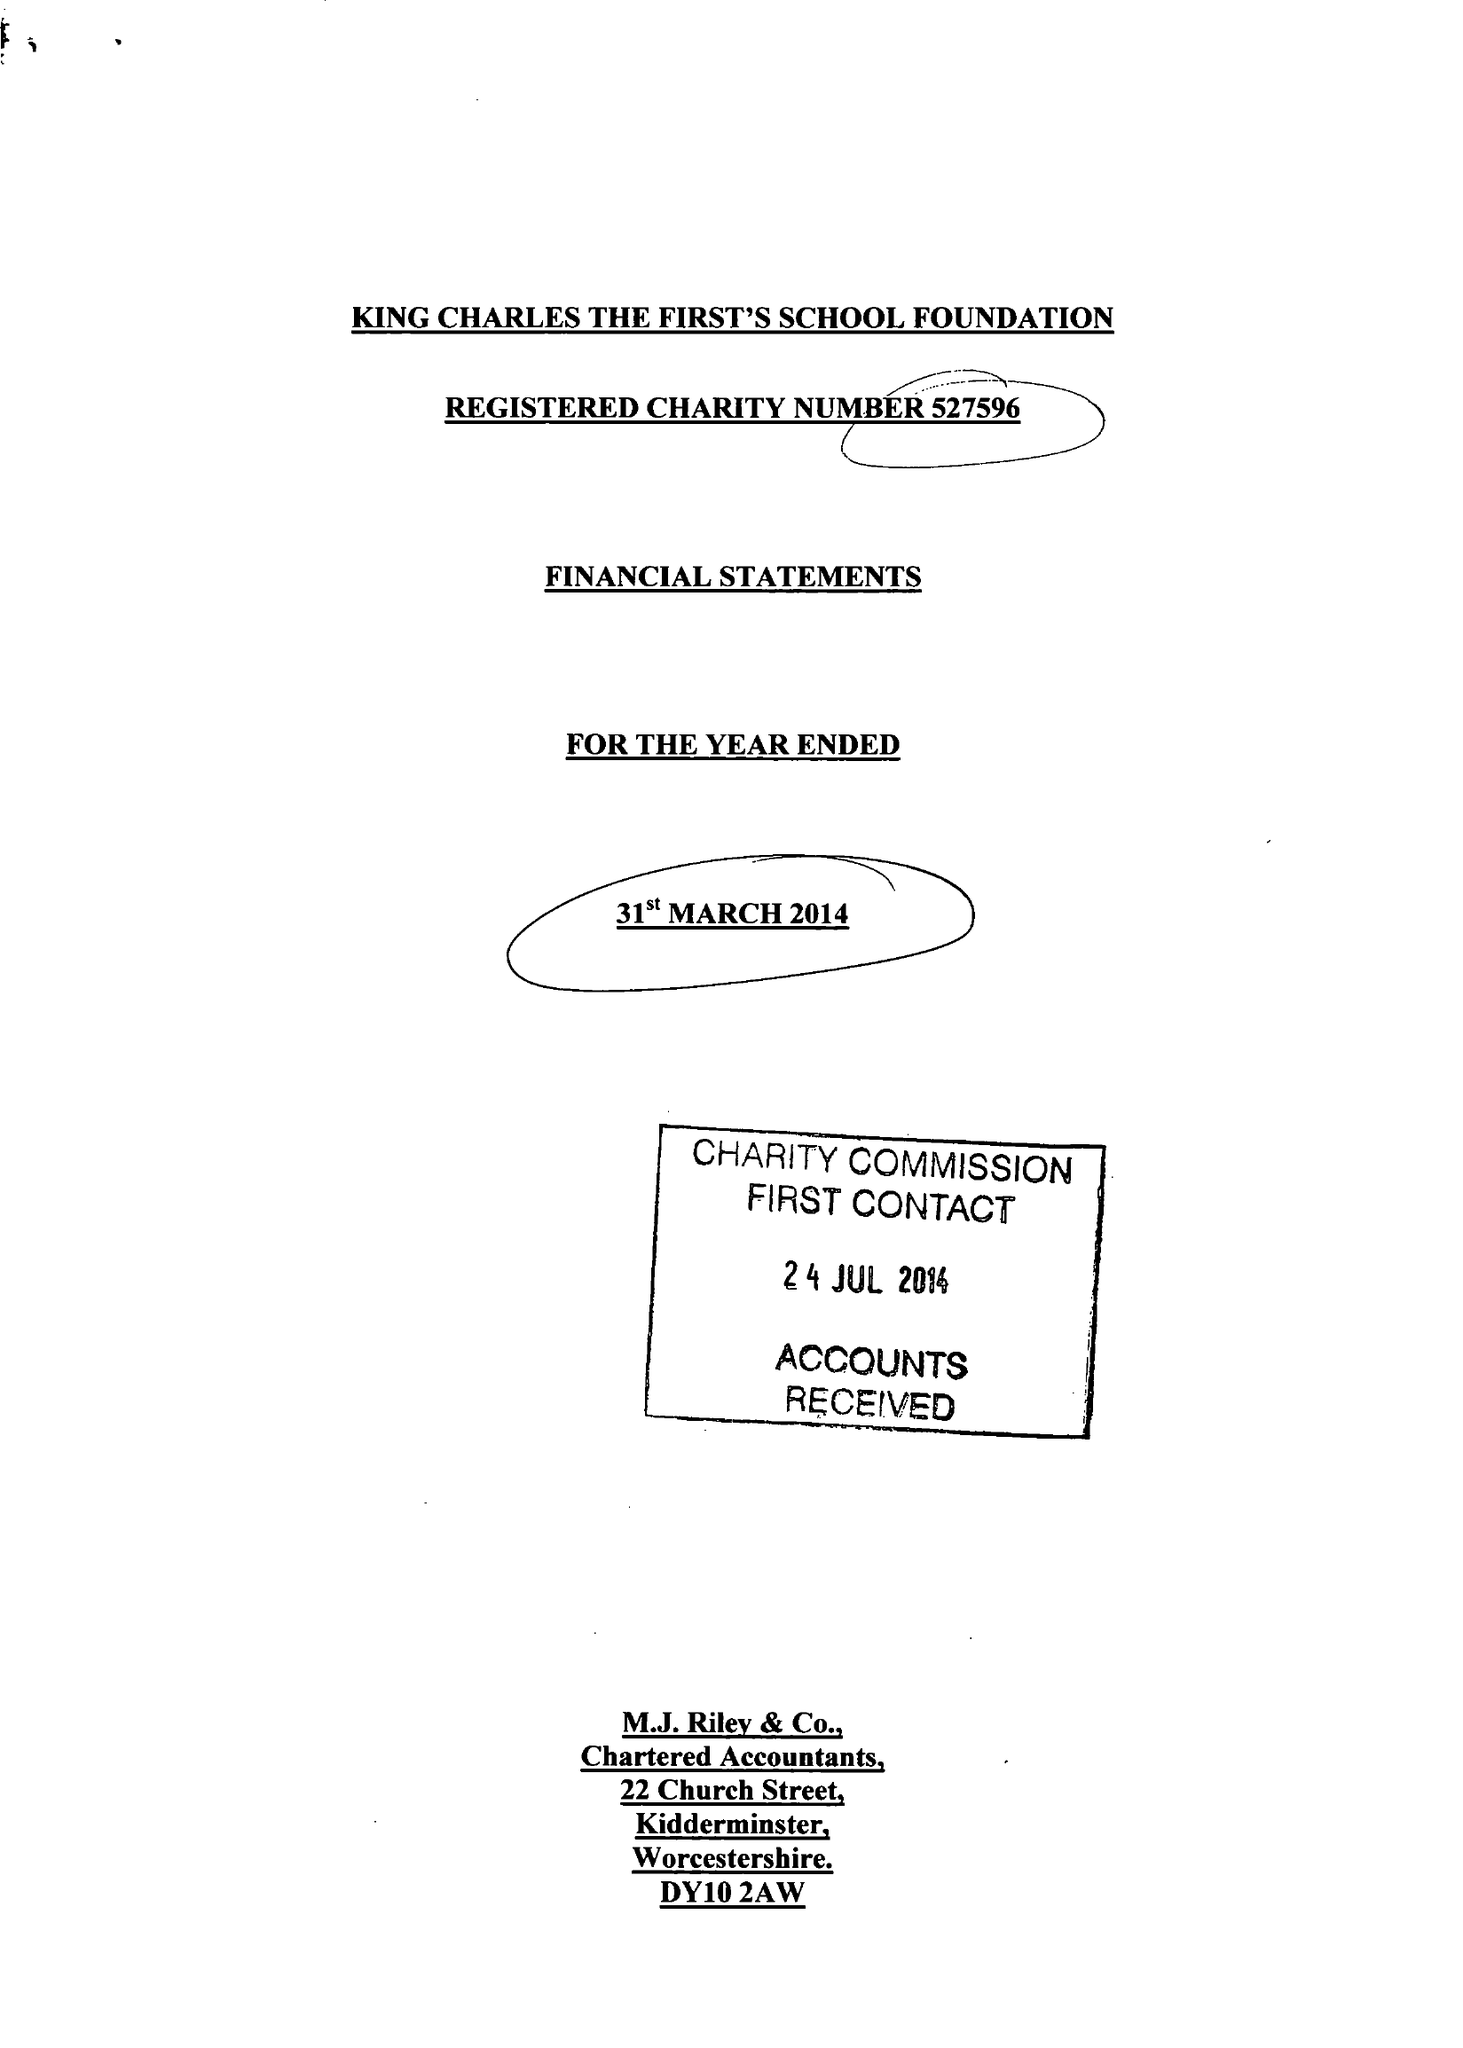What is the value for the spending_annually_in_british_pounds?
Answer the question using a single word or phrase. 64671.00 